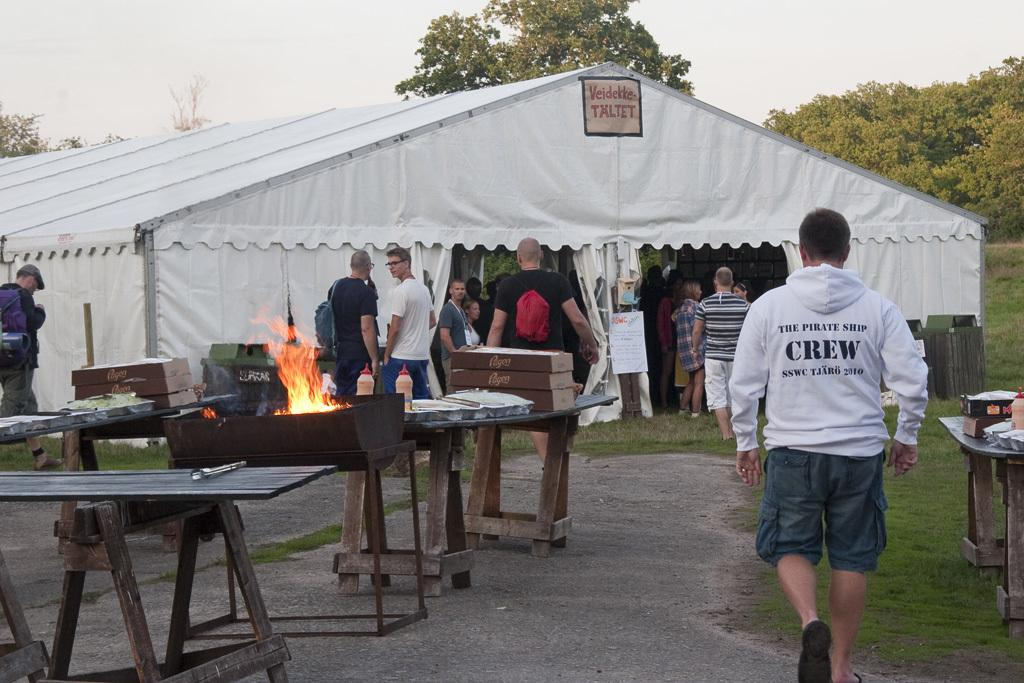What structure is visible in the image? There is a tent in the image. What is happening on the tent? There is a group of people on the tent. What furniture is present in front of the tent? There are wooden tables in front of the tent. Are there any people outside the tent? Yes, there are people outside the tent. What type of question is being asked by the person holding the rifle in the image? There is no person holding a rifle in the image, and therefore no question is being asked. 